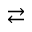Convert formula to latex. <formula><loc_0><loc_0><loc_500><loc_500>\right l e f t a r r o w s</formula> 